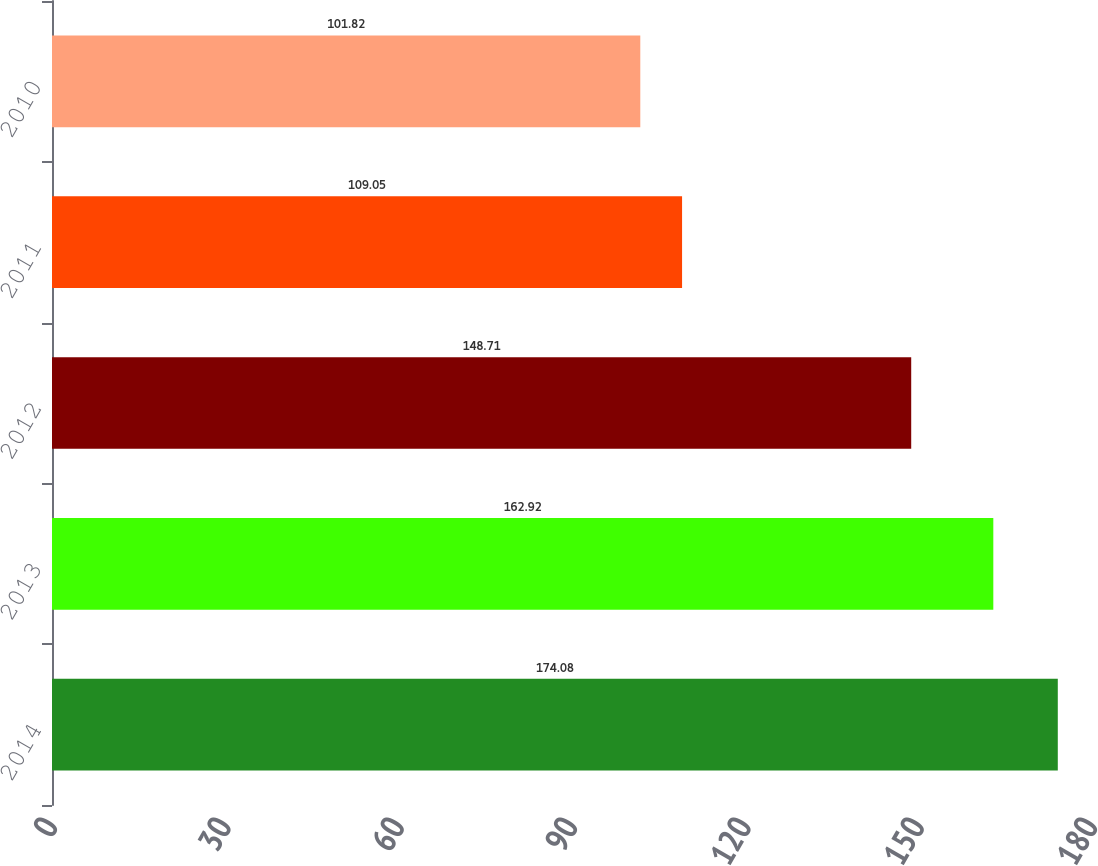Convert chart to OTSL. <chart><loc_0><loc_0><loc_500><loc_500><bar_chart><fcel>2014<fcel>2013<fcel>2012<fcel>2011<fcel>2010<nl><fcel>174.08<fcel>162.92<fcel>148.71<fcel>109.05<fcel>101.82<nl></chart> 